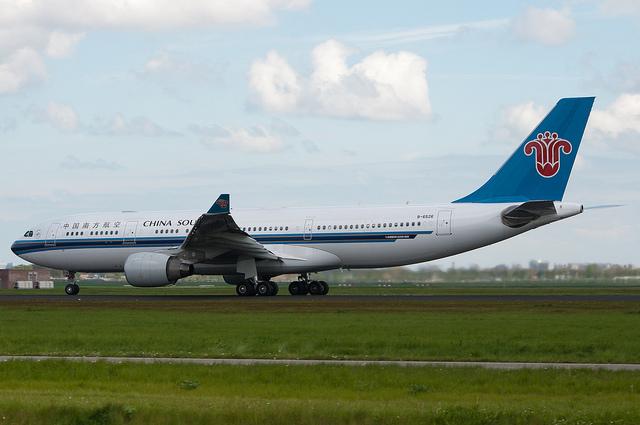How many engines on the plane?
Quick response, please. 2. Do you think the plane just landed?
Keep it brief. Yes. Is the plane on the grass?
Concise answer only. No. 